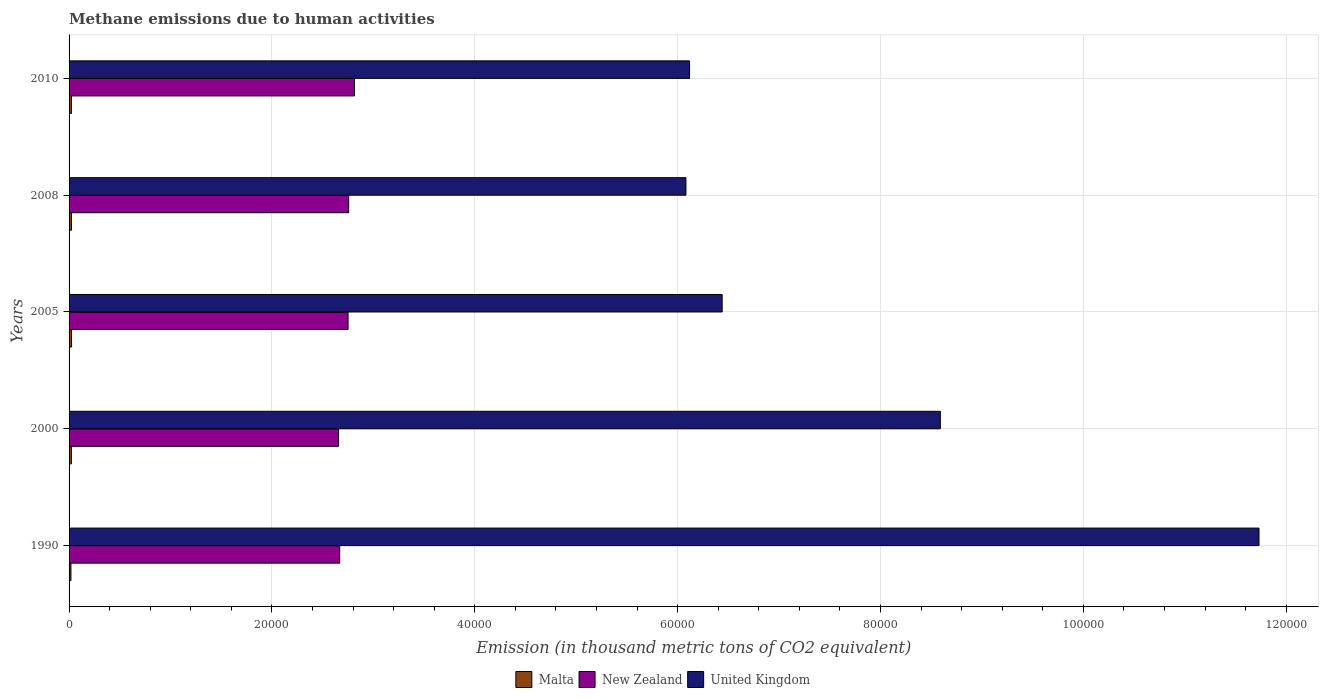How many different coloured bars are there?
Give a very brief answer. 3. Are the number of bars on each tick of the Y-axis equal?
Offer a very short reply. Yes. How many bars are there on the 1st tick from the top?
Give a very brief answer. 3. How many bars are there on the 5th tick from the bottom?
Make the answer very short. 3. In how many cases, is the number of bars for a given year not equal to the number of legend labels?
Provide a short and direct response. 0. What is the amount of methane emitted in New Zealand in 2010?
Give a very brief answer. 2.81e+04. Across all years, what is the maximum amount of methane emitted in New Zealand?
Your response must be concise. 2.81e+04. Across all years, what is the minimum amount of methane emitted in United Kingdom?
Your response must be concise. 6.08e+04. What is the total amount of methane emitted in New Zealand in the graph?
Your response must be concise. 1.36e+05. What is the difference between the amount of methane emitted in United Kingdom in 1990 and that in 2005?
Ensure brevity in your answer.  5.29e+04. What is the difference between the amount of methane emitted in Malta in 2010 and the amount of methane emitted in New Zealand in 2008?
Provide a short and direct response. -2.73e+04. What is the average amount of methane emitted in Malta per year?
Your answer should be compact. 225.9. In the year 2000, what is the difference between the amount of methane emitted in Malta and amount of methane emitted in New Zealand?
Make the answer very short. -2.63e+04. What is the ratio of the amount of methane emitted in United Kingdom in 2005 to that in 2010?
Ensure brevity in your answer.  1.05. Is the amount of methane emitted in United Kingdom in 2008 less than that in 2010?
Offer a very short reply. Yes. Is the difference between the amount of methane emitted in Malta in 2008 and 2010 greater than the difference between the amount of methane emitted in New Zealand in 2008 and 2010?
Keep it short and to the point. Yes. What is the difference between the highest and the second highest amount of methane emitted in United Kingdom?
Offer a terse response. 3.14e+04. What is the difference between the highest and the lowest amount of methane emitted in New Zealand?
Provide a succinct answer. 1563.1. In how many years, is the amount of methane emitted in Malta greater than the average amount of methane emitted in Malta taken over all years?
Offer a terse response. 4. Is the sum of the amount of methane emitted in Malta in 1990 and 2000 greater than the maximum amount of methane emitted in New Zealand across all years?
Your answer should be very brief. No. What does the 3rd bar from the top in 1990 represents?
Provide a succinct answer. Malta. What does the 1st bar from the bottom in 2000 represents?
Offer a terse response. Malta. How many bars are there?
Provide a succinct answer. 15. What is the difference between two consecutive major ticks on the X-axis?
Provide a short and direct response. 2.00e+04. Are the values on the major ticks of X-axis written in scientific E-notation?
Your answer should be compact. No. What is the title of the graph?
Provide a succinct answer. Methane emissions due to human activities. What is the label or title of the X-axis?
Provide a succinct answer. Emission (in thousand metric tons of CO2 equivalent). What is the Emission (in thousand metric tons of CO2 equivalent) of Malta in 1990?
Provide a succinct answer. 183.7. What is the Emission (in thousand metric tons of CO2 equivalent) of New Zealand in 1990?
Your answer should be very brief. 2.67e+04. What is the Emission (in thousand metric tons of CO2 equivalent) of United Kingdom in 1990?
Your answer should be very brief. 1.17e+05. What is the Emission (in thousand metric tons of CO2 equivalent) in Malta in 2000?
Give a very brief answer. 230.8. What is the Emission (in thousand metric tons of CO2 equivalent) in New Zealand in 2000?
Give a very brief answer. 2.66e+04. What is the Emission (in thousand metric tons of CO2 equivalent) of United Kingdom in 2000?
Make the answer very short. 8.59e+04. What is the Emission (in thousand metric tons of CO2 equivalent) of Malta in 2005?
Provide a succinct answer. 245.1. What is the Emission (in thousand metric tons of CO2 equivalent) of New Zealand in 2005?
Ensure brevity in your answer.  2.75e+04. What is the Emission (in thousand metric tons of CO2 equivalent) of United Kingdom in 2005?
Offer a very short reply. 6.44e+04. What is the Emission (in thousand metric tons of CO2 equivalent) of Malta in 2008?
Keep it short and to the point. 234.5. What is the Emission (in thousand metric tons of CO2 equivalent) in New Zealand in 2008?
Your answer should be compact. 2.76e+04. What is the Emission (in thousand metric tons of CO2 equivalent) of United Kingdom in 2008?
Make the answer very short. 6.08e+04. What is the Emission (in thousand metric tons of CO2 equivalent) in Malta in 2010?
Provide a succinct answer. 235.4. What is the Emission (in thousand metric tons of CO2 equivalent) in New Zealand in 2010?
Your response must be concise. 2.81e+04. What is the Emission (in thousand metric tons of CO2 equivalent) of United Kingdom in 2010?
Provide a short and direct response. 6.12e+04. Across all years, what is the maximum Emission (in thousand metric tons of CO2 equivalent) in Malta?
Your response must be concise. 245.1. Across all years, what is the maximum Emission (in thousand metric tons of CO2 equivalent) in New Zealand?
Your answer should be compact. 2.81e+04. Across all years, what is the maximum Emission (in thousand metric tons of CO2 equivalent) of United Kingdom?
Provide a succinct answer. 1.17e+05. Across all years, what is the minimum Emission (in thousand metric tons of CO2 equivalent) of Malta?
Provide a succinct answer. 183.7. Across all years, what is the minimum Emission (in thousand metric tons of CO2 equivalent) in New Zealand?
Provide a short and direct response. 2.66e+04. Across all years, what is the minimum Emission (in thousand metric tons of CO2 equivalent) in United Kingdom?
Give a very brief answer. 6.08e+04. What is the total Emission (in thousand metric tons of CO2 equivalent) in Malta in the graph?
Provide a succinct answer. 1129.5. What is the total Emission (in thousand metric tons of CO2 equivalent) in New Zealand in the graph?
Offer a very short reply. 1.36e+05. What is the total Emission (in thousand metric tons of CO2 equivalent) in United Kingdom in the graph?
Your response must be concise. 3.90e+05. What is the difference between the Emission (in thousand metric tons of CO2 equivalent) in Malta in 1990 and that in 2000?
Provide a short and direct response. -47.1. What is the difference between the Emission (in thousand metric tons of CO2 equivalent) of New Zealand in 1990 and that in 2000?
Your answer should be compact. 110.6. What is the difference between the Emission (in thousand metric tons of CO2 equivalent) of United Kingdom in 1990 and that in 2000?
Offer a very short reply. 3.14e+04. What is the difference between the Emission (in thousand metric tons of CO2 equivalent) in Malta in 1990 and that in 2005?
Your answer should be compact. -61.4. What is the difference between the Emission (in thousand metric tons of CO2 equivalent) of New Zealand in 1990 and that in 2005?
Your response must be concise. -824. What is the difference between the Emission (in thousand metric tons of CO2 equivalent) of United Kingdom in 1990 and that in 2005?
Offer a terse response. 5.29e+04. What is the difference between the Emission (in thousand metric tons of CO2 equivalent) in Malta in 1990 and that in 2008?
Keep it short and to the point. -50.8. What is the difference between the Emission (in thousand metric tons of CO2 equivalent) in New Zealand in 1990 and that in 2008?
Keep it short and to the point. -885.5. What is the difference between the Emission (in thousand metric tons of CO2 equivalent) of United Kingdom in 1990 and that in 2008?
Provide a short and direct response. 5.65e+04. What is the difference between the Emission (in thousand metric tons of CO2 equivalent) of Malta in 1990 and that in 2010?
Give a very brief answer. -51.7. What is the difference between the Emission (in thousand metric tons of CO2 equivalent) of New Zealand in 1990 and that in 2010?
Your answer should be compact. -1452.5. What is the difference between the Emission (in thousand metric tons of CO2 equivalent) of United Kingdom in 1990 and that in 2010?
Your answer should be very brief. 5.61e+04. What is the difference between the Emission (in thousand metric tons of CO2 equivalent) in Malta in 2000 and that in 2005?
Offer a very short reply. -14.3. What is the difference between the Emission (in thousand metric tons of CO2 equivalent) in New Zealand in 2000 and that in 2005?
Your response must be concise. -934.6. What is the difference between the Emission (in thousand metric tons of CO2 equivalent) in United Kingdom in 2000 and that in 2005?
Provide a short and direct response. 2.15e+04. What is the difference between the Emission (in thousand metric tons of CO2 equivalent) of New Zealand in 2000 and that in 2008?
Ensure brevity in your answer.  -996.1. What is the difference between the Emission (in thousand metric tons of CO2 equivalent) in United Kingdom in 2000 and that in 2008?
Ensure brevity in your answer.  2.51e+04. What is the difference between the Emission (in thousand metric tons of CO2 equivalent) of Malta in 2000 and that in 2010?
Offer a terse response. -4.6. What is the difference between the Emission (in thousand metric tons of CO2 equivalent) of New Zealand in 2000 and that in 2010?
Give a very brief answer. -1563.1. What is the difference between the Emission (in thousand metric tons of CO2 equivalent) of United Kingdom in 2000 and that in 2010?
Make the answer very short. 2.47e+04. What is the difference between the Emission (in thousand metric tons of CO2 equivalent) of Malta in 2005 and that in 2008?
Your answer should be very brief. 10.6. What is the difference between the Emission (in thousand metric tons of CO2 equivalent) of New Zealand in 2005 and that in 2008?
Offer a terse response. -61.5. What is the difference between the Emission (in thousand metric tons of CO2 equivalent) in United Kingdom in 2005 and that in 2008?
Make the answer very short. 3573.1. What is the difference between the Emission (in thousand metric tons of CO2 equivalent) of New Zealand in 2005 and that in 2010?
Keep it short and to the point. -628.5. What is the difference between the Emission (in thousand metric tons of CO2 equivalent) of United Kingdom in 2005 and that in 2010?
Give a very brief answer. 3212.9. What is the difference between the Emission (in thousand metric tons of CO2 equivalent) in New Zealand in 2008 and that in 2010?
Your answer should be very brief. -567. What is the difference between the Emission (in thousand metric tons of CO2 equivalent) of United Kingdom in 2008 and that in 2010?
Offer a very short reply. -360.2. What is the difference between the Emission (in thousand metric tons of CO2 equivalent) in Malta in 1990 and the Emission (in thousand metric tons of CO2 equivalent) in New Zealand in 2000?
Your response must be concise. -2.64e+04. What is the difference between the Emission (in thousand metric tons of CO2 equivalent) in Malta in 1990 and the Emission (in thousand metric tons of CO2 equivalent) in United Kingdom in 2000?
Make the answer very short. -8.57e+04. What is the difference between the Emission (in thousand metric tons of CO2 equivalent) of New Zealand in 1990 and the Emission (in thousand metric tons of CO2 equivalent) of United Kingdom in 2000?
Provide a short and direct response. -5.92e+04. What is the difference between the Emission (in thousand metric tons of CO2 equivalent) in Malta in 1990 and the Emission (in thousand metric tons of CO2 equivalent) in New Zealand in 2005?
Offer a very short reply. -2.73e+04. What is the difference between the Emission (in thousand metric tons of CO2 equivalent) of Malta in 1990 and the Emission (in thousand metric tons of CO2 equivalent) of United Kingdom in 2005?
Make the answer very short. -6.42e+04. What is the difference between the Emission (in thousand metric tons of CO2 equivalent) of New Zealand in 1990 and the Emission (in thousand metric tons of CO2 equivalent) of United Kingdom in 2005?
Give a very brief answer. -3.77e+04. What is the difference between the Emission (in thousand metric tons of CO2 equivalent) in Malta in 1990 and the Emission (in thousand metric tons of CO2 equivalent) in New Zealand in 2008?
Your answer should be compact. -2.74e+04. What is the difference between the Emission (in thousand metric tons of CO2 equivalent) of Malta in 1990 and the Emission (in thousand metric tons of CO2 equivalent) of United Kingdom in 2008?
Provide a short and direct response. -6.06e+04. What is the difference between the Emission (in thousand metric tons of CO2 equivalent) in New Zealand in 1990 and the Emission (in thousand metric tons of CO2 equivalent) in United Kingdom in 2008?
Give a very brief answer. -3.41e+04. What is the difference between the Emission (in thousand metric tons of CO2 equivalent) of Malta in 1990 and the Emission (in thousand metric tons of CO2 equivalent) of New Zealand in 2010?
Your answer should be compact. -2.79e+04. What is the difference between the Emission (in thousand metric tons of CO2 equivalent) of Malta in 1990 and the Emission (in thousand metric tons of CO2 equivalent) of United Kingdom in 2010?
Make the answer very short. -6.10e+04. What is the difference between the Emission (in thousand metric tons of CO2 equivalent) of New Zealand in 1990 and the Emission (in thousand metric tons of CO2 equivalent) of United Kingdom in 2010?
Your answer should be compact. -3.45e+04. What is the difference between the Emission (in thousand metric tons of CO2 equivalent) in Malta in 2000 and the Emission (in thousand metric tons of CO2 equivalent) in New Zealand in 2005?
Provide a short and direct response. -2.73e+04. What is the difference between the Emission (in thousand metric tons of CO2 equivalent) in Malta in 2000 and the Emission (in thousand metric tons of CO2 equivalent) in United Kingdom in 2005?
Give a very brief answer. -6.42e+04. What is the difference between the Emission (in thousand metric tons of CO2 equivalent) in New Zealand in 2000 and the Emission (in thousand metric tons of CO2 equivalent) in United Kingdom in 2005?
Keep it short and to the point. -3.78e+04. What is the difference between the Emission (in thousand metric tons of CO2 equivalent) in Malta in 2000 and the Emission (in thousand metric tons of CO2 equivalent) in New Zealand in 2008?
Your response must be concise. -2.73e+04. What is the difference between the Emission (in thousand metric tons of CO2 equivalent) in Malta in 2000 and the Emission (in thousand metric tons of CO2 equivalent) in United Kingdom in 2008?
Ensure brevity in your answer.  -6.06e+04. What is the difference between the Emission (in thousand metric tons of CO2 equivalent) in New Zealand in 2000 and the Emission (in thousand metric tons of CO2 equivalent) in United Kingdom in 2008?
Ensure brevity in your answer.  -3.42e+04. What is the difference between the Emission (in thousand metric tons of CO2 equivalent) in Malta in 2000 and the Emission (in thousand metric tons of CO2 equivalent) in New Zealand in 2010?
Offer a very short reply. -2.79e+04. What is the difference between the Emission (in thousand metric tons of CO2 equivalent) in Malta in 2000 and the Emission (in thousand metric tons of CO2 equivalent) in United Kingdom in 2010?
Your answer should be very brief. -6.09e+04. What is the difference between the Emission (in thousand metric tons of CO2 equivalent) of New Zealand in 2000 and the Emission (in thousand metric tons of CO2 equivalent) of United Kingdom in 2010?
Your answer should be compact. -3.46e+04. What is the difference between the Emission (in thousand metric tons of CO2 equivalent) of Malta in 2005 and the Emission (in thousand metric tons of CO2 equivalent) of New Zealand in 2008?
Your response must be concise. -2.73e+04. What is the difference between the Emission (in thousand metric tons of CO2 equivalent) in Malta in 2005 and the Emission (in thousand metric tons of CO2 equivalent) in United Kingdom in 2008?
Ensure brevity in your answer.  -6.06e+04. What is the difference between the Emission (in thousand metric tons of CO2 equivalent) in New Zealand in 2005 and the Emission (in thousand metric tons of CO2 equivalent) in United Kingdom in 2008?
Offer a very short reply. -3.33e+04. What is the difference between the Emission (in thousand metric tons of CO2 equivalent) of Malta in 2005 and the Emission (in thousand metric tons of CO2 equivalent) of New Zealand in 2010?
Provide a succinct answer. -2.79e+04. What is the difference between the Emission (in thousand metric tons of CO2 equivalent) in Malta in 2005 and the Emission (in thousand metric tons of CO2 equivalent) in United Kingdom in 2010?
Your answer should be very brief. -6.09e+04. What is the difference between the Emission (in thousand metric tons of CO2 equivalent) of New Zealand in 2005 and the Emission (in thousand metric tons of CO2 equivalent) of United Kingdom in 2010?
Keep it short and to the point. -3.37e+04. What is the difference between the Emission (in thousand metric tons of CO2 equivalent) of Malta in 2008 and the Emission (in thousand metric tons of CO2 equivalent) of New Zealand in 2010?
Offer a very short reply. -2.79e+04. What is the difference between the Emission (in thousand metric tons of CO2 equivalent) of Malta in 2008 and the Emission (in thousand metric tons of CO2 equivalent) of United Kingdom in 2010?
Provide a succinct answer. -6.09e+04. What is the difference between the Emission (in thousand metric tons of CO2 equivalent) of New Zealand in 2008 and the Emission (in thousand metric tons of CO2 equivalent) of United Kingdom in 2010?
Make the answer very short. -3.36e+04. What is the average Emission (in thousand metric tons of CO2 equivalent) of Malta per year?
Your answer should be very brief. 225.9. What is the average Emission (in thousand metric tons of CO2 equivalent) in New Zealand per year?
Give a very brief answer. 2.73e+04. What is the average Emission (in thousand metric tons of CO2 equivalent) in United Kingdom per year?
Keep it short and to the point. 7.79e+04. In the year 1990, what is the difference between the Emission (in thousand metric tons of CO2 equivalent) in Malta and Emission (in thousand metric tons of CO2 equivalent) in New Zealand?
Your answer should be compact. -2.65e+04. In the year 1990, what is the difference between the Emission (in thousand metric tons of CO2 equivalent) of Malta and Emission (in thousand metric tons of CO2 equivalent) of United Kingdom?
Your answer should be compact. -1.17e+05. In the year 1990, what is the difference between the Emission (in thousand metric tons of CO2 equivalent) in New Zealand and Emission (in thousand metric tons of CO2 equivalent) in United Kingdom?
Your answer should be compact. -9.06e+04. In the year 2000, what is the difference between the Emission (in thousand metric tons of CO2 equivalent) of Malta and Emission (in thousand metric tons of CO2 equivalent) of New Zealand?
Offer a very short reply. -2.63e+04. In the year 2000, what is the difference between the Emission (in thousand metric tons of CO2 equivalent) in Malta and Emission (in thousand metric tons of CO2 equivalent) in United Kingdom?
Provide a short and direct response. -8.57e+04. In the year 2000, what is the difference between the Emission (in thousand metric tons of CO2 equivalent) of New Zealand and Emission (in thousand metric tons of CO2 equivalent) of United Kingdom?
Offer a very short reply. -5.93e+04. In the year 2005, what is the difference between the Emission (in thousand metric tons of CO2 equivalent) of Malta and Emission (in thousand metric tons of CO2 equivalent) of New Zealand?
Offer a very short reply. -2.73e+04. In the year 2005, what is the difference between the Emission (in thousand metric tons of CO2 equivalent) of Malta and Emission (in thousand metric tons of CO2 equivalent) of United Kingdom?
Your answer should be compact. -6.41e+04. In the year 2005, what is the difference between the Emission (in thousand metric tons of CO2 equivalent) of New Zealand and Emission (in thousand metric tons of CO2 equivalent) of United Kingdom?
Offer a very short reply. -3.69e+04. In the year 2008, what is the difference between the Emission (in thousand metric tons of CO2 equivalent) of Malta and Emission (in thousand metric tons of CO2 equivalent) of New Zealand?
Provide a short and direct response. -2.73e+04. In the year 2008, what is the difference between the Emission (in thousand metric tons of CO2 equivalent) in Malta and Emission (in thousand metric tons of CO2 equivalent) in United Kingdom?
Make the answer very short. -6.06e+04. In the year 2008, what is the difference between the Emission (in thousand metric tons of CO2 equivalent) of New Zealand and Emission (in thousand metric tons of CO2 equivalent) of United Kingdom?
Your answer should be very brief. -3.32e+04. In the year 2010, what is the difference between the Emission (in thousand metric tons of CO2 equivalent) of Malta and Emission (in thousand metric tons of CO2 equivalent) of New Zealand?
Provide a succinct answer. -2.79e+04. In the year 2010, what is the difference between the Emission (in thousand metric tons of CO2 equivalent) of Malta and Emission (in thousand metric tons of CO2 equivalent) of United Kingdom?
Your answer should be very brief. -6.09e+04. In the year 2010, what is the difference between the Emission (in thousand metric tons of CO2 equivalent) in New Zealand and Emission (in thousand metric tons of CO2 equivalent) in United Kingdom?
Make the answer very short. -3.30e+04. What is the ratio of the Emission (in thousand metric tons of CO2 equivalent) of Malta in 1990 to that in 2000?
Provide a succinct answer. 0.8. What is the ratio of the Emission (in thousand metric tons of CO2 equivalent) of United Kingdom in 1990 to that in 2000?
Ensure brevity in your answer.  1.37. What is the ratio of the Emission (in thousand metric tons of CO2 equivalent) of Malta in 1990 to that in 2005?
Make the answer very short. 0.75. What is the ratio of the Emission (in thousand metric tons of CO2 equivalent) of New Zealand in 1990 to that in 2005?
Give a very brief answer. 0.97. What is the ratio of the Emission (in thousand metric tons of CO2 equivalent) of United Kingdom in 1990 to that in 2005?
Provide a succinct answer. 1.82. What is the ratio of the Emission (in thousand metric tons of CO2 equivalent) of Malta in 1990 to that in 2008?
Ensure brevity in your answer.  0.78. What is the ratio of the Emission (in thousand metric tons of CO2 equivalent) of New Zealand in 1990 to that in 2008?
Your answer should be very brief. 0.97. What is the ratio of the Emission (in thousand metric tons of CO2 equivalent) of United Kingdom in 1990 to that in 2008?
Give a very brief answer. 1.93. What is the ratio of the Emission (in thousand metric tons of CO2 equivalent) in Malta in 1990 to that in 2010?
Offer a terse response. 0.78. What is the ratio of the Emission (in thousand metric tons of CO2 equivalent) in New Zealand in 1990 to that in 2010?
Your answer should be very brief. 0.95. What is the ratio of the Emission (in thousand metric tons of CO2 equivalent) in United Kingdom in 1990 to that in 2010?
Your answer should be compact. 1.92. What is the ratio of the Emission (in thousand metric tons of CO2 equivalent) of Malta in 2000 to that in 2005?
Provide a succinct answer. 0.94. What is the ratio of the Emission (in thousand metric tons of CO2 equivalent) in New Zealand in 2000 to that in 2005?
Your response must be concise. 0.97. What is the ratio of the Emission (in thousand metric tons of CO2 equivalent) of United Kingdom in 2000 to that in 2005?
Offer a terse response. 1.33. What is the ratio of the Emission (in thousand metric tons of CO2 equivalent) of Malta in 2000 to that in 2008?
Offer a very short reply. 0.98. What is the ratio of the Emission (in thousand metric tons of CO2 equivalent) in New Zealand in 2000 to that in 2008?
Provide a succinct answer. 0.96. What is the ratio of the Emission (in thousand metric tons of CO2 equivalent) of United Kingdom in 2000 to that in 2008?
Your answer should be very brief. 1.41. What is the ratio of the Emission (in thousand metric tons of CO2 equivalent) of Malta in 2000 to that in 2010?
Your answer should be very brief. 0.98. What is the ratio of the Emission (in thousand metric tons of CO2 equivalent) of United Kingdom in 2000 to that in 2010?
Your answer should be compact. 1.4. What is the ratio of the Emission (in thousand metric tons of CO2 equivalent) in Malta in 2005 to that in 2008?
Give a very brief answer. 1.05. What is the ratio of the Emission (in thousand metric tons of CO2 equivalent) in New Zealand in 2005 to that in 2008?
Keep it short and to the point. 1. What is the ratio of the Emission (in thousand metric tons of CO2 equivalent) of United Kingdom in 2005 to that in 2008?
Provide a short and direct response. 1.06. What is the ratio of the Emission (in thousand metric tons of CO2 equivalent) of Malta in 2005 to that in 2010?
Keep it short and to the point. 1.04. What is the ratio of the Emission (in thousand metric tons of CO2 equivalent) of New Zealand in 2005 to that in 2010?
Your answer should be very brief. 0.98. What is the ratio of the Emission (in thousand metric tons of CO2 equivalent) in United Kingdom in 2005 to that in 2010?
Your answer should be compact. 1.05. What is the ratio of the Emission (in thousand metric tons of CO2 equivalent) in Malta in 2008 to that in 2010?
Your response must be concise. 1. What is the ratio of the Emission (in thousand metric tons of CO2 equivalent) of New Zealand in 2008 to that in 2010?
Make the answer very short. 0.98. What is the difference between the highest and the second highest Emission (in thousand metric tons of CO2 equivalent) in New Zealand?
Your answer should be very brief. 567. What is the difference between the highest and the second highest Emission (in thousand metric tons of CO2 equivalent) of United Kingdom?
Offer a terse response. 3.14e+04. What is the difference between the highest and the lowest Emission (in thousand metric tons of CO2 equivalent) of Malta?
Make the answer very short. 61.4. What is the difference between the highest and the lowest Emission (in thousand metric tons of CO2 equivalent) of New Zealand?
Offer a terse response. 1563.1. What is the difference between the highest and the lowest Emission (in thousand metric tons of CO2 equivalent) of United Kingdom?
Provide a succinct answer. 5.65e+04. 